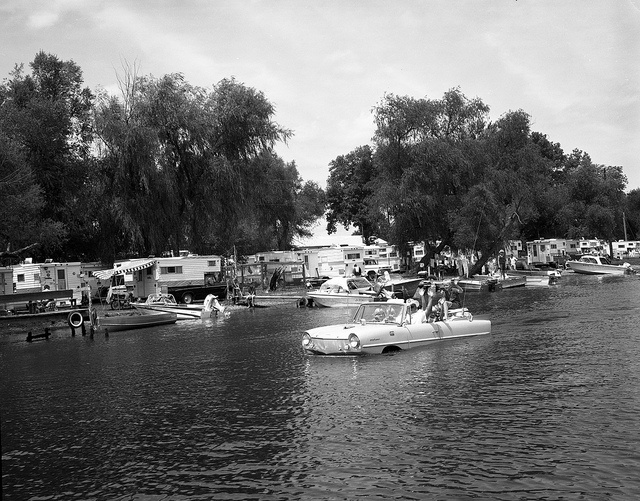Describe the objects in this image and their specific colors. I can see car in lightgray, darkgray, gray, and black tones, boat in lightgray, darkgray, gray, and black tones, boat in lightgray, gray, black, and darkgray tones, truck in lightgray, black, gray, and darkgray tones, and boat in lightgray, darkgray, gray, and black tones in this image. 